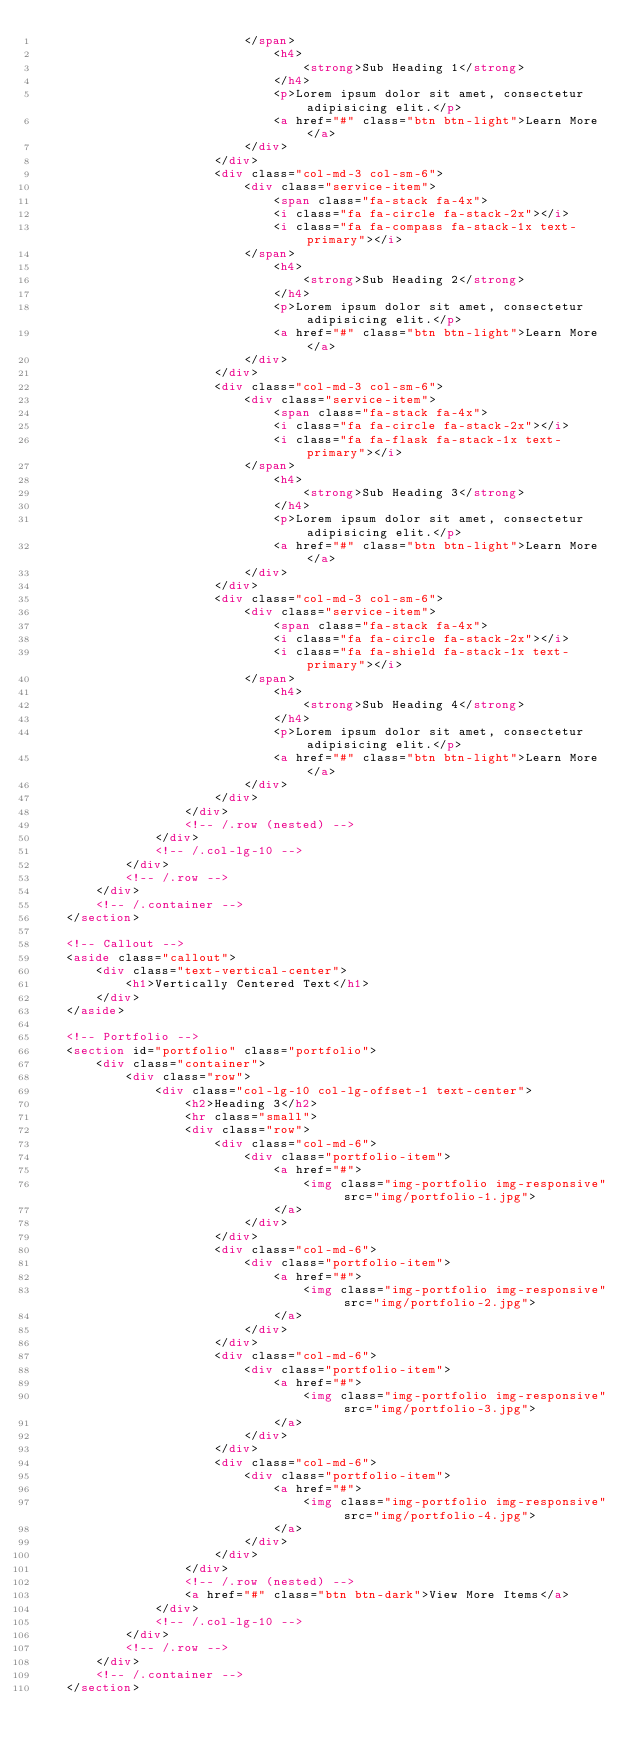Convert code to text. <code><loc_0><loc_0><loc_500><loc_500><_HTML_>                            </span>
                                <h4>
                                    <strong>Sub Heading 1</strong>
                                </h4>
                                <p>Lorem ipsum dolor sit amet, consectetur adipisicing elit.</p>
                                <a href="#" class="btn btn-light">Learn More</a>
                            </div>
                        </div>
                        <div class="col-md-3 col-sm-6">
                            <div class="service-item">
                                <span class="fa-stack fa-4x">
                                <i class="fa fa-circle fa-stack-2x"></i>
                                <i class="fa fa-compass fa-stack-1x text-primary"></i>
                            </span>
                                <h4>
                                    <strong>Sub Heading 2</strong>
                                </h4>
                                <p>Lorem ipsum dolor sit amet, consectetur adipisicing elit.</p>
                                <a href="#" class="btn btn-light">Learn More</a>
                            </div>
                        </div>
                        <div class="col-md-3 col-sm-6">
                            <div class="service-item">
                                <span class="fa-stack fa-4x">
                                <i class="fa fa-circle fa-stack-2x"></i>
                                <i class="fa fa-flask fa-stack-1x text-primary"></i>
                            </span>
                                <h4>
                                    <strong>Sub Heading 3</strong>
                                </h4>
                                <p>Lorem ipsum dolor sit amet, consectetur adipisicing elit.</p>
                                <a href="#" class="btn btn-light">Learn More</a>
                            </div>
                        </div>
                        <div class="col-md-3 col-sm-6">
                            <div class="service-item">
                                <span class="fa-stack fa-4x">
                                <i class="fa fa-circle fa-stack-2x"></i>
                                <i class="fa fa-shield fa-stack-1x text-primary"></i>
                            </span>
                                <h4>
                                    <strong>Sub Heading 4</strong>
                                </h4>
                                <p>Lorem ipsum dolor sit amet, consectetur adipisicing elit.</p>
                                <a href="#" class="btn btn-light">Learn More</a>
                            </div>
                        </div>
                    </div>
                    <!-- /.row (nested) -->
                </div>
                <!-- /.col-lg-10 -->
            </div>
            <!-- /.row -->
        </div>
        <!-- /.container -->
    </section>

    <!-- Callout -->
    <aside class="callout">
        <div class="text-vertical-center">
            <h1>Vertically Centered Text</h1>
        </div>
    </aside>

    <!-- Portfolio -->
    <section id="portfolio" class="portfolio">
        <div class="container">
            <div class="row">
                <div class="col-lg-10 col-lg-offset-1 text-center">
                    <h2>Heading 3</h2>
                    <hr class="small">
                    <div class="row">
                        <div class="col-md-6">
                            <div class="portfolio-item">
                                <a href="#">
                                    <img class="img-portfolio img-responsive" src="img/portfolio-1.jpg">
                                </a>
                            </div>
                        </div>
                        <div class="col-md-6">
                            <div class="portfolio-item">
                                <a href="#">
                                    <img class="img-portfolio img-responsive" src="img/portfolio-2.jpg">
                                </a>
                            </div>
                        </div>
                        <div class="col-md-6">
                            <div class="portfolio-item">
                                <a href="#">
                                    <img class="img-portfolio img-responsive" src="img/portfolio-3.jpg">
                                </a>
                            </div>
                        </div>
                        <div class="col-md-6">
                            <div class="portfolio-item">
                                <a href="#">
                                    <img class="img-portfolio img-responsive" src="img/portfolio-4.jpg">
                                </a>
                            </div>
                        </div>
                    </div>
                    <!-- /.row (nested) -->
                    <a href="#" class="btn btn-dark">View More Items</a>
                </div>
                <!-- /.col-lg-10 -->
            </div>
            <!-- /.row -->
        </div>
        <!-- /.container -->
    </section>
</code> 